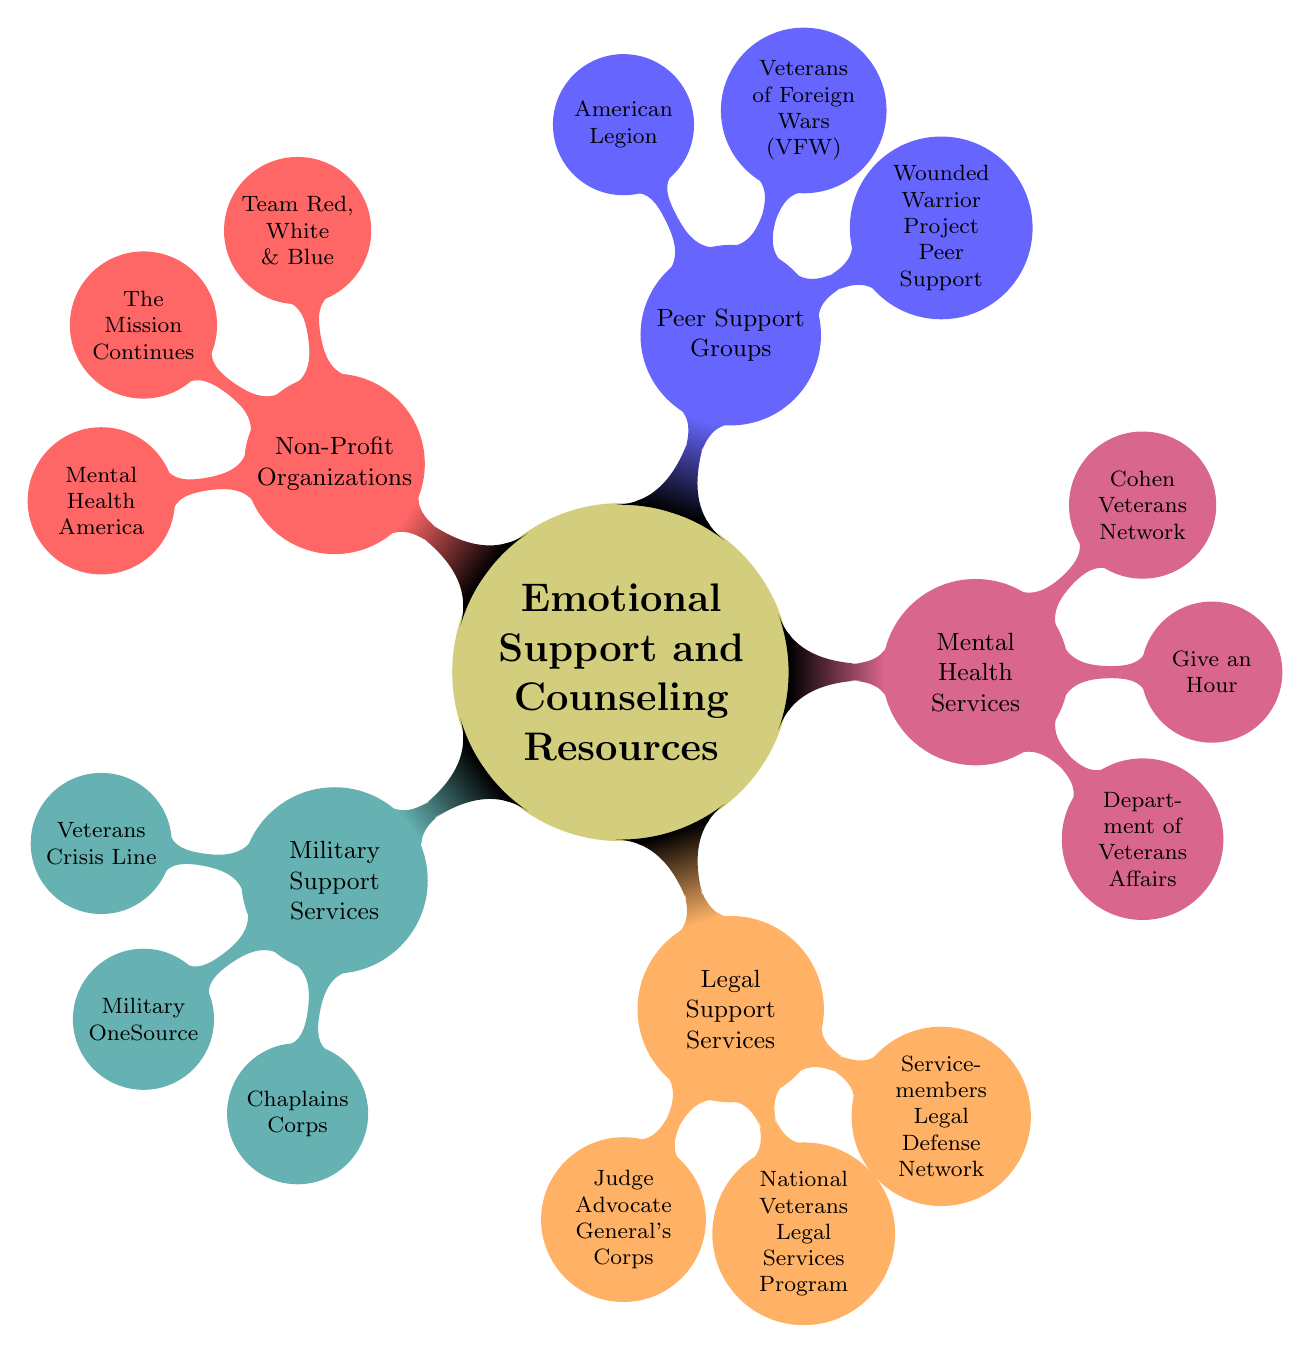What are the three main categories of resources in the diagram? The diagram presents five main categories of resources: Military Support Services, Legal Support Services, Mental Health Services, Peer Support Groups, and Non-Profit Organizations. To answer the question, we simply enumerate the categories listed in the top-level nodes of the mind map.
Answer: Military Support Services, Legal Support Services, Mental Health Services, Peer Support Groups, Non-Profit Organizations How many resources are listed under Mental Health Services? In the Mental Health Services category, there are three resources: Department of Veterans Affairs, Give an Hour, and Cohen Veterans Network. The count of nodes connected to the Mental Health Services node gives us the answer.
Answer: 3 Which support group focuses on community and advocacy for veterans? The Veterans of Foreign Wars (VFW) is specifically highlighted in the Peer Support Groups section for its community support and advocacy for veterans. Reading the description of each node under Peer Support Groups helps identify this resource.
Answer: Veterans of Foreign Wars (VFW) What type of assistance does the Judge Advocate General's Corps provide? The Judge Advocate General's Corps offers legal representation and advice for service members. This information can be found by looking at the description connected to the Judge Advocate General's Corps node.
Answer: Legal representation and advice Which organization provides free counseling by licensed mental health professionals? Give an Hour is the organization mentioned in the Mental Health Services section that provides free counseling by licensed mental health professionals. We find this by reviewing the details under the Mental Health Services node.
Answer: Give an Hour How many organizations are listed under the Non-Profit Organizations category? There are three organizations listed under the Non-Profit Organizations category: Team Red, White & Blue, The Mission Continues, and Mental Health America. The answer is determined by counting the number of nodes branching from Non-Profit Organizations.
Answer: 3 Which organization focuses on veterans serving in community-based volunteer projects? The Mission Continues is the organization that provides opportunities for veterans to serve in community-based volunteer projects. This is found by examining the description linked to The Mission Continues node in the Non-Profit Organizations section.
Answer: The Mission Continues What type of guidance does the Chaplains Corps offer? The Chaplains Corps offers spiritual and emotional guidance, which is specified in its description under the Military Support Services category. This helps clarify the focus of this resource.
Answer: Spiritual and emotional guidance 